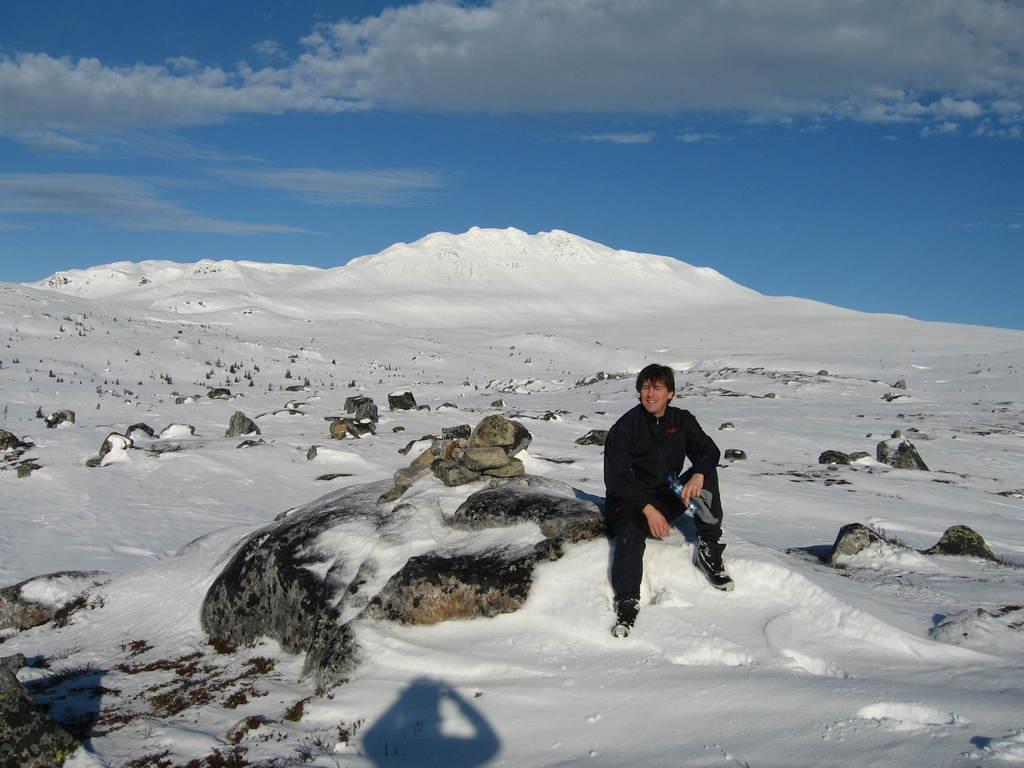How would you summarize this image in a sentence or two? In this image I can see the person and the person is wearing black color dress and holding some object and I can see few stones. In the background I can see the snow and the sky is in blue and white color. 